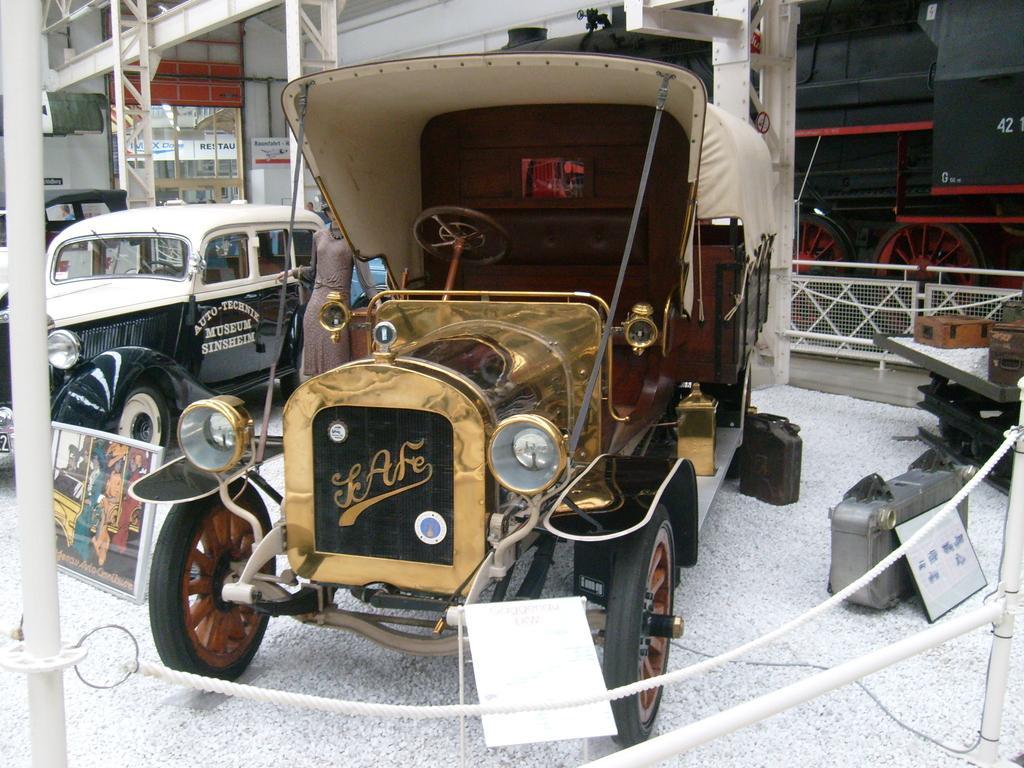Could you give a brief overview of what you see in this image? In this picture we can see the vehicles, boards, rope, rods, some other objects and a lady is standing. In the background of the image we can see the rods, boards, train, wall. At the bottom of the image we can see the stones. 